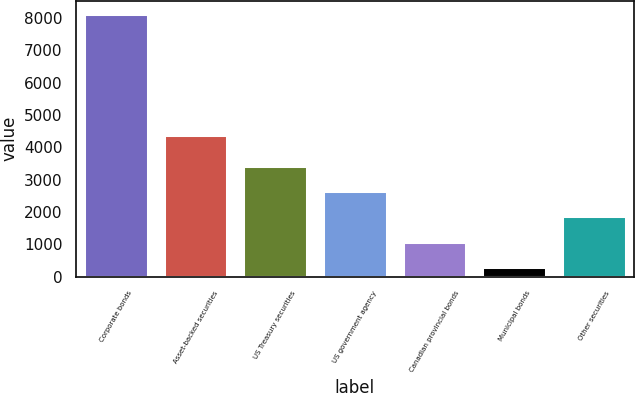<chart> <loc_0><loc_0><loc_500><loc_500><bar_chart><fcel>Corporate bonds<fcel>Asset-backed securities<fcel>US Treasury securities<fcel>US government agency<fcel>Canadian provincial bonds<fcel>Municipal bonds<fcel>Other securities<nl><fcel>8127.1<fcel>4383.6<fcel>3431.92<fcel>2649.39<fcel>1084.33<fcel>301.8<fcel>1866.86<nl></chart> 